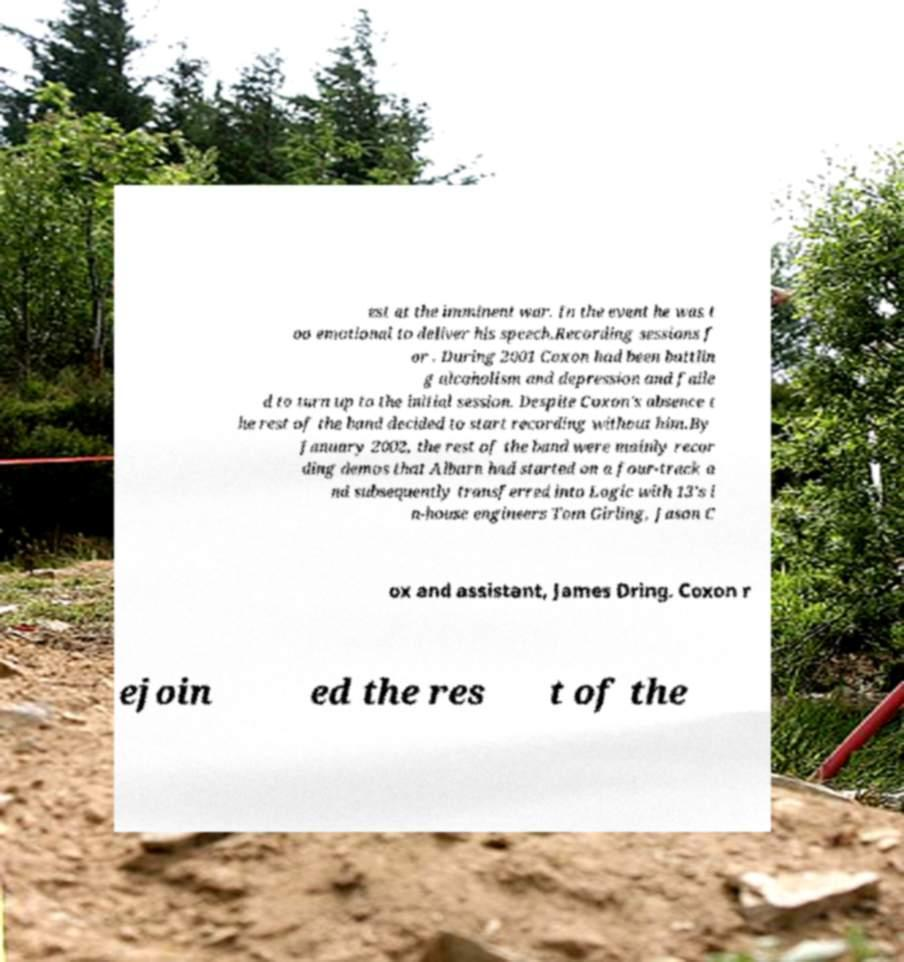Can you read and provide the text displayed in the image?This photo seems to have some interesting text. Can you extract and type it out for me? est at the imminent war. In the event he was t oo emotional to deliver his speech.Recording sessions f or . During 2001 Coxon had been battlin g alcoholism and depression and faile d to turn up to the initial session. Despite Coxon's absence t he rest of the band decided to start recording without him.By January 2002, the rest of the band were mainly recor ding demos that Albarn had started on a four-track a nd subsequently transferred into Logic with 13's i n-house engineers Tom Girling, Jason C ox and assistant, James Dring. Coxon r ejoin ed the res t of the 